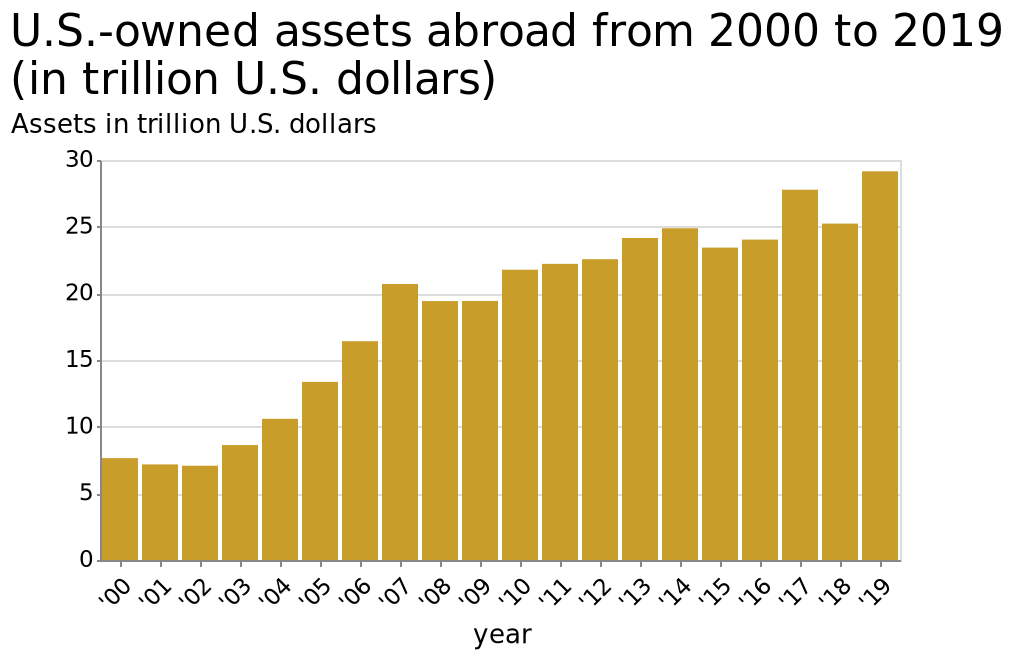<image>
please describe the details of the chart U.S.-owned assets abroad from 2000 to 2019 (in trillion U.S. dollars) is a bar plot. There is a linear scale of range 0 to 30 along the y-axis, marked Assets in trillion U.S. dollars. There is a categorical scale starting at '00 and ending at '19 on the x-axis, labeled year. 